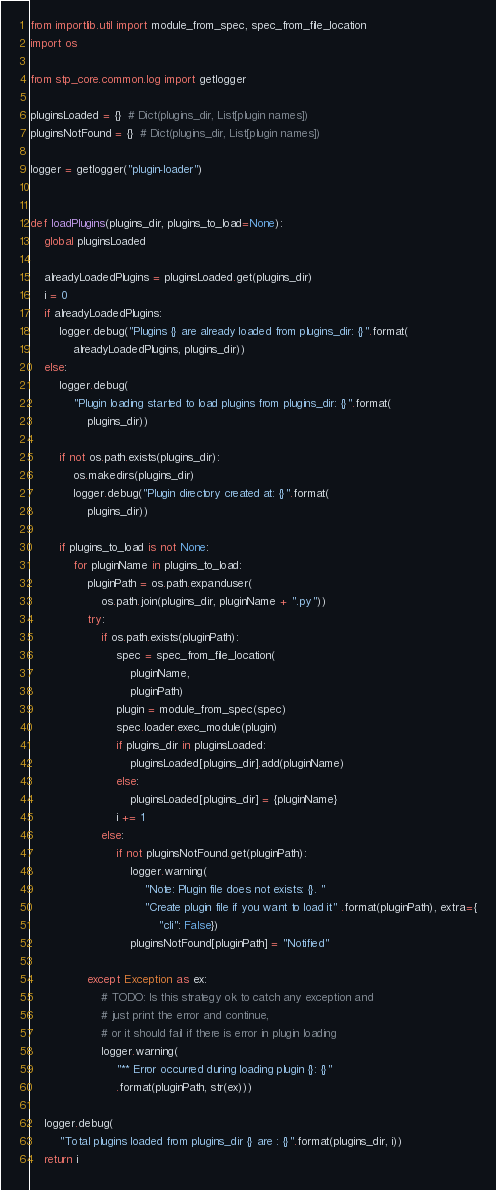Convert code to text. <code><loc_0><loc_0><loc_500><loc_500><_Python_>from importlib.util import module_from_spec, spec_from_file_location
import os

from stp_core.common.log import getlogger

pluginsLoaded = {}  # Dict(plugins_dir, List[plugin names])
pluginsNotFound = {}  # Dict(plugins_dir, List[plugin names])

logger = getlogger("plugin-loader")


def loadPlugins(plugins_dir, plugins_to_load=None):
    global pluginsLoaded

    alreadyLoadedPlugins = pluginsLoaded.get(plugins_dir)
    i = 0
    if alreadyLoadedPlugins:
        logger.debug("Plugins {} are already loaded from plugins_dir: {}".format(
            alreadyLoadedPlugins, plugins_dir))
    else:
        logger.debug(
            "Plugin loading started to load plugins from plugins_dir: {}".format(
                plugins_dir))

        if not os.path.exists(plugins_dir):
            os.makedirs(plugins_dir)
            logger.debug("Plugin directory created at: {}".format(
                plugins_dir))

        if plugins_to_load is not None:
            for pluginName in plugins_to_load:
                pluginPath = os.path.expanduser(
                    os.path.join(plugins_dir, pluginName + ".py"))
                try:
                    if os.path.exists(pluginPath):
                        spec = spec_from_file_location(
                            pluginName,
                            pluginPath)
                        plugin = module_from_spec(spec)
                        spec.loader.exec_module(plugin)
                        if plugins_dir in pluginsLoaded:
                            pluginsLoaded[plugins_dir].add(pluginName)
                        else:
                            pluginsLoaded[plugins_dir] = {pluginName}
                        i += 1
                    else:
                        if not pluginsNotFound.get(pluginPath):
                            logger.warning(
                                "Note: Plugin file does not exists: {}. "
                                "Create plugin file if you want to load it" .format(pluginPath), extra={
                                    "cli": False})
                            pluginsNotFound[pluginPath] = "Notified"

                except Exception as ex:
                    # TODO: Is this strategy ok to catch any exception and
                    # just print the error and continue,
                    # or it should fail if there is error in plugin loading
                    logger.warning(
                        "** Error occurred during loading plugin {}: {}"
                        .format(pluginPath, str(ex)))

    logger.debug(
        "Total plugins loaded from plugins_dir {} are : {}".format(plugins_dir, i))
    return i
</code> 